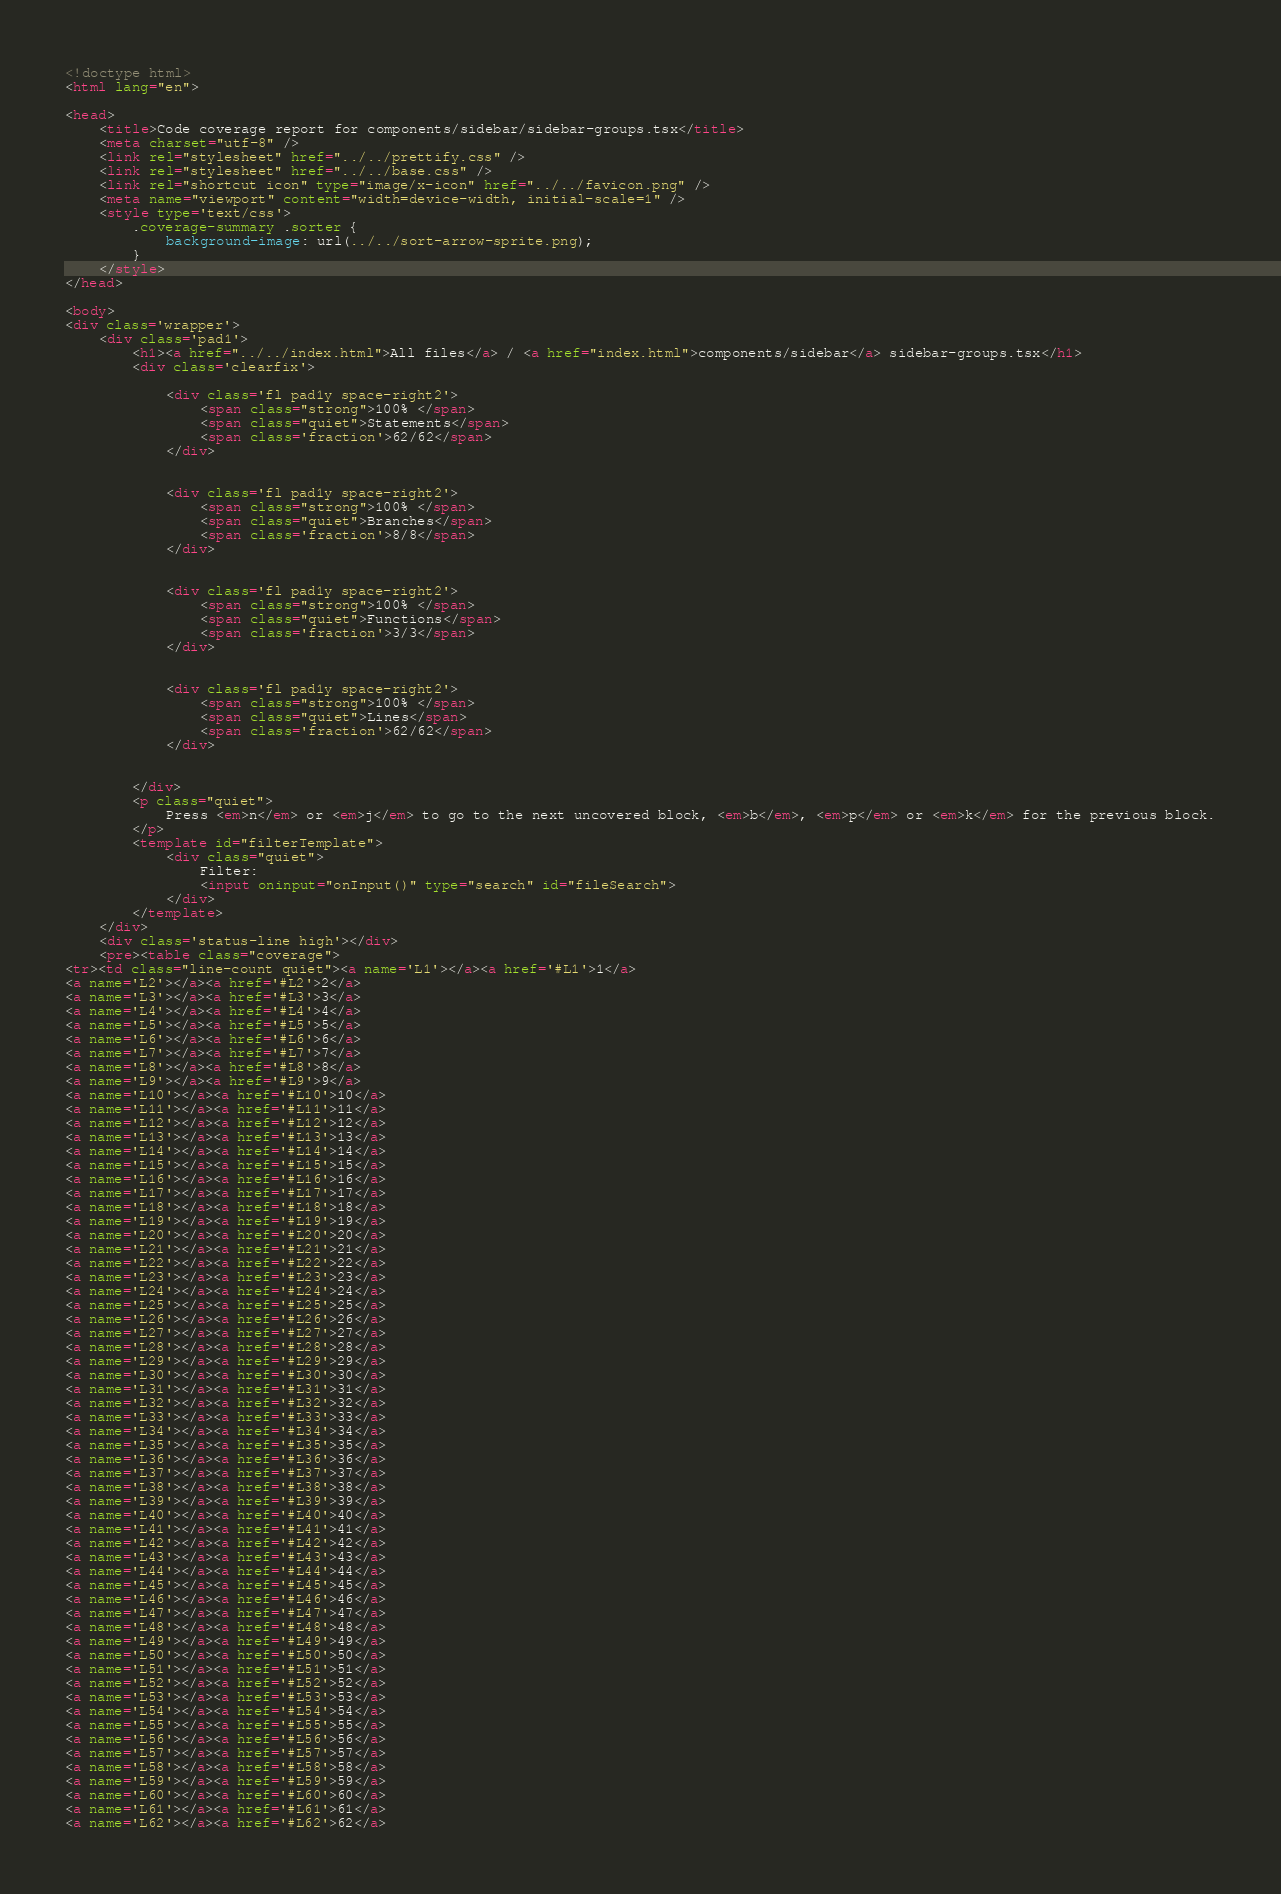<code> <loc_0><loc_0><loc_500><loc_500><_HTML_>
<!doctype html>
<html lang="en">

<head>
    <title>Code coverage report for components/sidebar/sidebar-groups.tsx</title>
    <meta charset="utf-8" />
    <link rel="stylesheet" href="../../prettify.css" />
    <link rel="stylesheet" href="../../base.css" />
    <link rel="shortcut icon" type="image/x-icon" href="../../favicon.png" />
    <meta name="viewport" content="width=device-width, initial-scale=1" />
    <style type='text/css'>
        .coverage-summary .sorter {
            background-image: url(../../sort-arrow-sprite.png);
        }
    </style>
</head>
    
<body>
<div class='wrapper'>
    <div class='pad1'>
        <h1><a href="../../index.html">All files</a> / <a href="index.html">components/sidebar</a> sidebar-groups.tsx</h1>
        <div class='clearfix'>
            
            <div class='fl pad1y space-right2'>
                <span class="strong">100% </span>
                <span class="quiet">Statements</span>
                <span class='fraction'>62/62</span>
            </div>
        
            
            <div class='fl pad1y space-right2'>
                <span class="strong">100% </span>
                <span class="quiet">Branches</span>
                <span class='fraction'>8/8</span>
            </div>
        
            
            <div class='fl pad1y space-right2'>
                <span class="strong">100% </span>
                <span class="quiet">Functions</span>
                <span class='fraction'>3/3</span>
            </div>
        
            
            <div class='fl pad1y space-right2'>
                <span class="strong">100% </span>
                <span class="quiet">Lines</span>
                <span class='fraction'>62/62</span>
            </div>
        
            
        </div>
        <p class="quiet">
            Press <em>n</em> or <em>j</em> to go to the next uncovered block, <em>b</em>, <em>p</em> or <em>k</em> for the previous block.
        </p>
        <template id="filterTemplate">
            <div class="quiet">
                Filter:
                <input oninput="onInput()" type="search" id="fileSearch">
            </div>
        </template>
    </div>
    <div class='status-line high'></div>
    <pre><table class="coverage">
<tr><td class="line-count quiet"><a name='L1'></a><a href='#L1'>1</a>
<a name='L2'></a><a href='#L2'>2</a>
<a name='L3'></a><a href='#L3'>3</a>
<a name='L4'></a><a href='#L4'>4</a>
<a name='L5'></a><a href='#L5'>5</a>
<a name='L6'></a><a href='#L6'>6</a>
<a name='L7'></a><a href='#L7'>7</a>
<a name='L8'></a><a href='#L8'>8</a>
<a name='L9'></a><a href='#L9'>9</a>
<a name='L10'></a><a href='#L10'>10</a>
<a name='L11'></a><a href='#L11'>11</a>
<a name='L12'></a><a href='#L12'>12</a>
<a name='L13'></a><a href='#L13'>13</a>
<a name='L14'></a><a href='#L14'>14</a>
<a name='L15'></a><a href='#L15'>15</a>
<a name='L16'></a><a href='#L16'>16</a>
<a name='L17'></a><a href='#L17'>17</a>
<a name='L18'></a><a href='#L18'>18</a>
<a name='L19'></a><a href='#L19'>19</a>
<a name='L20'></a><a href='#L20'>20</a>
<a name='L21'></a><a href='#L21'>21</a>
<a name='L22'></a><a href='#L22'>22</a>
<a name='L23'></a><a href='#L23'>23</a>
<a name='L24'></a><a href='#L24'>24</a>
<a name='L25'></a><a href='#L25'>25</a>
<a name='L26'></a><a href='#L26'>26</a>
<a name='L27'></a><a href='#L27'>27</a>
<a name='L28'></a><a href='#L28'>28</a>
<a name='L29'></a><a href='#L29'>29</a>
<a name='L30'></a><a href='#L30'>30</a>
<a name='L31'></a><a href='#L31'>31</a>
<a name='L32'></a><a href='#L32'>32</a>
<a name='L33'></a><a href='#L33'>33</a>
<a name='L34'></a><a href='#L34'>34</a>
<a name='L35'></a><a href='#L35'>35</a>
<a name='L36'></a><a href='#L36'>36</a>
<a name='L37'></a><a href='#L37'>37</a>
<a name='L38'></a><a href='#L38'>38</a>
<a name='L39'></a><a href='#L39'>39</a>
<a name='L40'></a><a href='#L40'>40</a>
<a name='L41'></a><a href='#L41'>41</a>
<a name='L42'></a><a href='#L42'>42</a>
<a name='L43'></a><a href='#L43'>43</a>
<a name='L44'></a><a href='#L44'>44</a>
<a name='L45'></a><a href='#L45'>45</a>
<a name='L46'></a><a href='#L46'>46</a>
<a name='L47'></a><a href='#L47'>47</a>
<a name='L48'></a><a href='#L48'>48</a>
<a name='L49'></a><a href='#L49'>49</a>
<a name='L50'></a><a href='#L50'>50</a>
<a name='L51'></a><a href='#L51'>51</a>
<a name='L52'></a><a href='#L52'>52</a>
<a name='L53'></a><a href='#L53'>53</a>
<a name='L54'></a><a href='#L54'>54</a>
<a name='L55'></a><a href='#L55'>55</a>
<a name='L56'></a><a href='#L56'>56</a>
<a name='L57'></a><a href='#L57'>57</a>
<a name='L58'></a><a href='#L58'>58</a>
<a name='L59'></a><a href='#L59'>59</a>
<a name='L60'></a><a href='#L60'>60</a>
<a name='L61'></a><a href='#L61'>61</a>
<a name='L62'></a><a href='#L62'>62</a></code> 